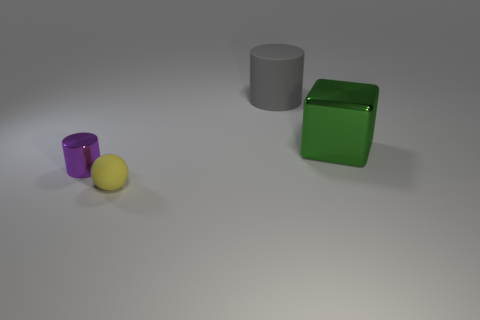Add 2 green blocks. How many objects exist? 6 Subtract all spheres. How many objects are left? 3 Subtract all small balls. Subtract all tiny matte spheres. How many objects are left? 2 Add 1 tiny metallic cylinders. How many tiny metallic cylinders are left? 2 Add 3 rubber cylinders. How many rubber cylinders exist? 4 Subtract 0 cyan cylinders. How many objects are left? 4 